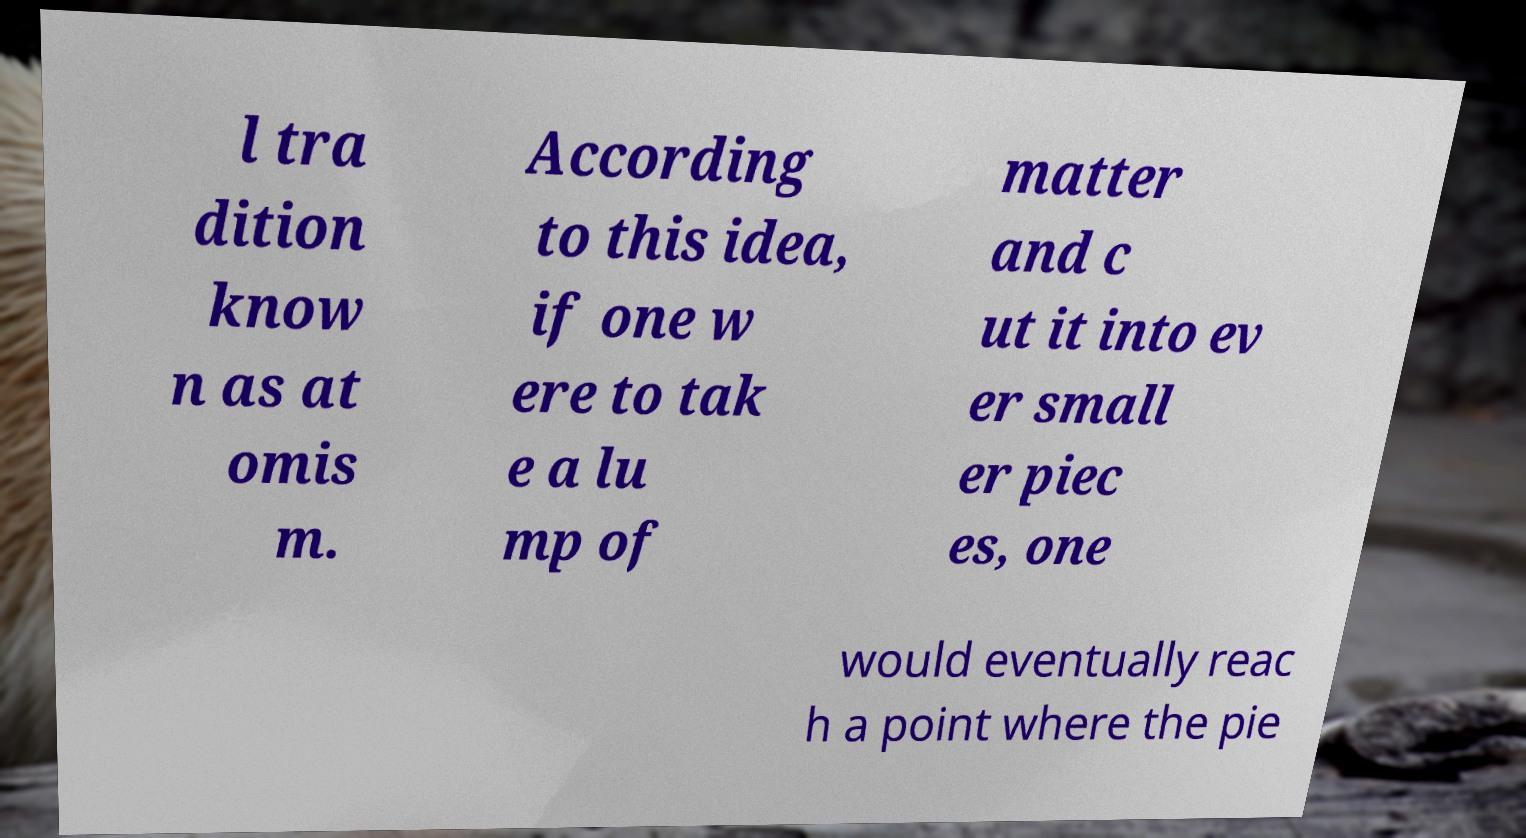There's text embedded in this image that I need extracted. Can you transcribe it verbatim? l tra dition know n as at omis m. According to this idea, if one w ere to tak e a lu mp of matter and c ut it into ev er small er piec es, one would eventually reac h a point where the pie 